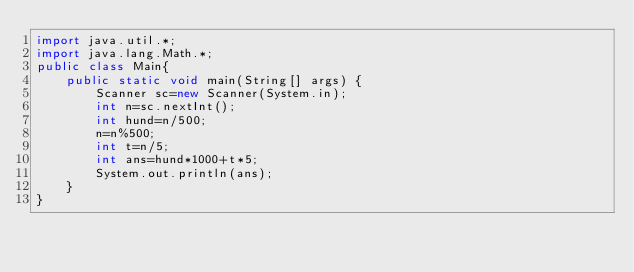<code> <loc_0><loc_0><loc_500><loc_500><_Java_>import java.util.*;
import java.lang.Math.*;
public class Main{
	public static void main(String[] args) {
		Scanner sc=new Scanner(System.in);
		int n=sc.nextInt();
		int hund=n/500;
		n=n%500;
		int t=n/5;
		int ans=hund*1000+t*5;
		System.out.println(ans);
	}
}</code> 